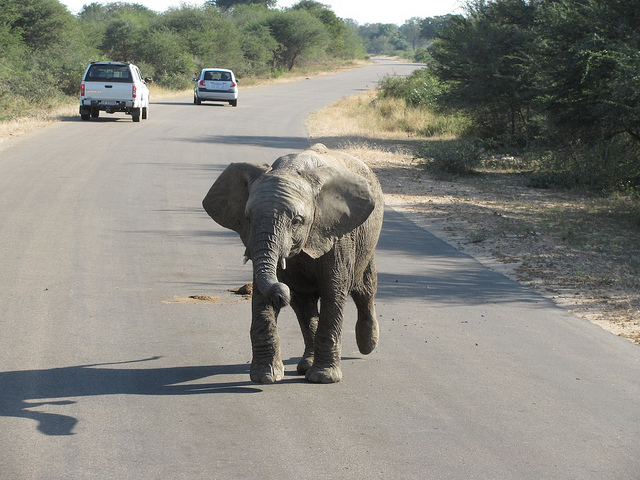Would ivory poachers be very tempted to hunt this elephant? It's not possible to gauge the intentions of poachers from an image alone. Generally, all elephants are at risk from ivory poaching due to the value of their tusks, and measures are in place to protect these majestic animals. 